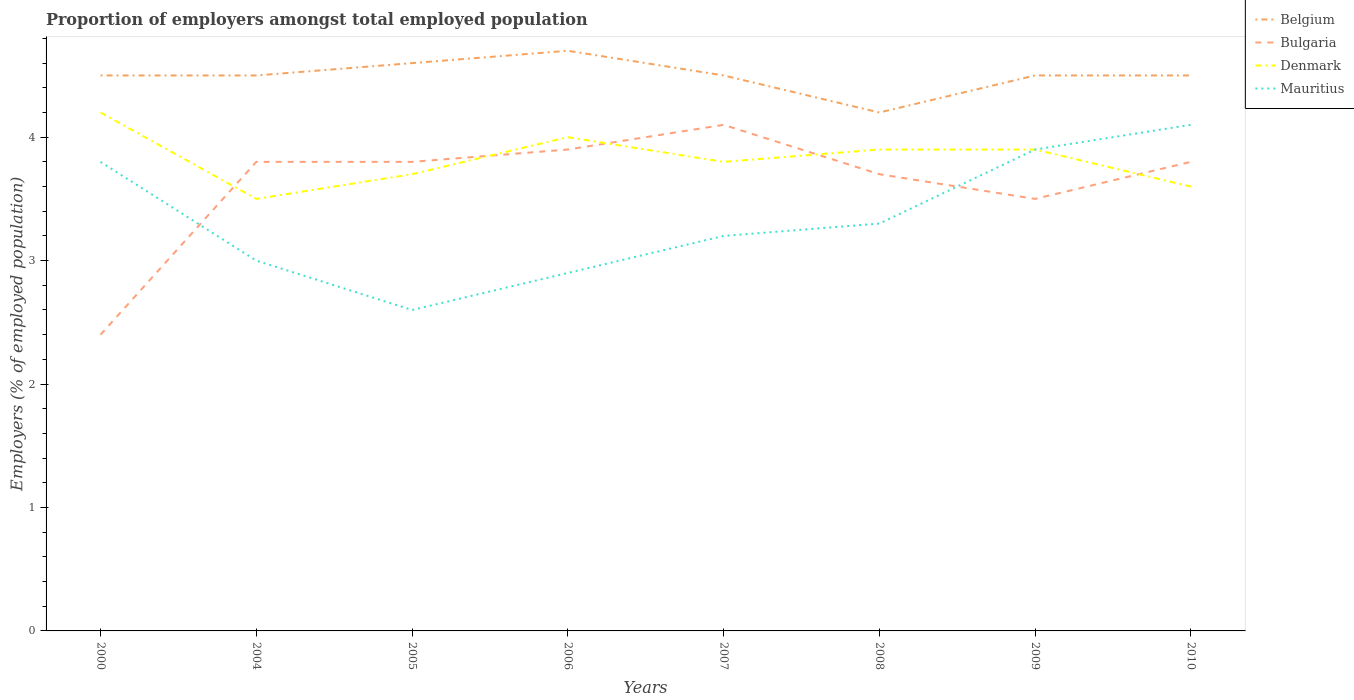Does the line corresponding to Bulgaria intersect with the line corresponding to Belgium?
Your answer should be very brief. No. Across all years, what is the maximum proportion of employers in Bulgaria?
Provide a short and direct response. 2.4. In which year was the proportion of employers in Mauritius maximum?
Make the answer very short. 2005. What is the total proportion of employers in Denmark in the graph?
Your response must be concise. -0.3. What is the difference between the highest and the second highest proportion of employers in Mauritius?
Keep it short and to the point. 1.5. What is the difference between the highest and the lowest proportion of employers in Mauritius?
Your response must be concise. 3. Is the proportion of employers in Bulgaria strictly greater than the proportion of employers in Denmark over the years?
Provide a short and direct response. No. How many lines are there?
Your answer should be very brief. 4. How many years are there in the graph?
Keep it short and to the point. 8. What is the difference between two consecutive major ticks on the Y-axis?
Ensure brevity in your answer.  1. Does the graph contain grids?
Your answer should be compact. No. How many legend labels are there?
Ensure brevity in your answer.  4. How are the legend labels stacked?
Your answer should be very brief. Vertical. What is the title of the graph?
Ensure brevity in your answer.  Proportion of employers amongst total employed population. Does "Somalia" appear as one of the legend labels in the graph?
Keep it short and to the point. No. What is the label or title of the Y-axis?
Your response must be concise. Employers (% of employed population). What is the Employers (% of employed population) of Bulgaria in 2000?
Keep it short and to the point. 2.4. What is the Employers (% of employed population) in Denmark in 2000?
Give a very brief answer. 4.2. What is the Employers (% of employed population) in Mauritius in 2000?
Your answer should be very brief. 3.8. What is the Employers (% of employed population) in Bulgaria in 2004?
Give a very brief answer. 3.8. What is the Employers (% of employed population) of Denmark in 2004?
Your answer should be compact. 3.5. What is the Employers (% of employed population) in Mauritius in 2004?
Keep it short and to the point. 3. What is the Employers (% of employed population) of Belgium in 2005?
Keep it short and to the point. 4.6. What is the Employers (% of employed population) in Bulgaria in 2005?
Ensure brevity in your answer.  3.8. What is the Employers (% of employed population) in Denmark in 2005?
Make the answer very short. 3.7. What is the Employers (% of employed population) in Mauritius in 2005?
Give a very brief answer. 2.6. What is the Employers (% of employed population) in Belgium in 2006?
Keep it short and to the point. 4.7. What is the Employers (% of employed population) in Bulgaria in 2006?
Your answer should be very brief. 3.9. What is the Employers (% of employed population) of Mauritius in 2006?
Give a very brief answer. 2.9. What is the Employers (% of employed population) in Belgium in 2007?
Your response must be concise. 4.5. What is the Employers (% of employed population) in Bulgaria in 2007?
Provide a short and direct response. 4.1. What is the Employers (% of employed population) in Denmark in 2007?
Provide a short and direct response. 3.8. What is the Employers (% of employed population) in Mauritius in 2007?
Offer a terse response. 3.2. What is the Employers (% of employed population) of Belgium in 2008?
Ensure brevity in your answer.  4.2. What is the Employers (% of employed population) of Bulgaria in 2008?
Your answer should be compact. 3.7. What is the Employers (% of employed population) of Denmark in 2008?
Give a very brief answer. 3.9. What is the Employers (% of employed population) of Mauritius in 2008?
Your answer should be compact. 3.3. What is the Employers (% of employed population) of Denmark in 2009?
Ensure brevity in your answer.  3.9. What is the Employers (% of employed population) of Mauritius in 2009?
Offer a terse response. 3.9. What is the Employers (% of employed population) of Bulgaria in 2010?
Provide a succinct answer. 3.8. What is the Employers (% of employed population) of Denmark in 2010?
Your answer should be very brief. 3.6. What is the Employers (% of employed population) of Mauritius in 2010?
Provide a short and direct response. 4.1. Across all years, what is the maximum Employers (% of employed population) in Belgium?
Ensure brevity in your answer.  4.7. Across all years, what is the maximum Employers (% of employed population) in Bulgaria?
Provide a succinct answer. 4.1. Across all years, what is the maximum Employers (% of employed population) in Denmark?
Your response must be concise. 4.2. Across all years, what is the maximum Employers (% of employed population) in Mauritius?
Provide a short and direct response. 4.1. Across all years, what is the minimum Employers (% of employed population) in Belgium?
Make the answer very short. 4.2. Across all years, what is the minimum Employers (% of employed population) in Bulgaria?
Ensure brevity in your answer.  2.4. Across all years, what is the minimum Employers (% of employed population) in Mauritius?
Provide a succinct answer. 2.6. What is the total Employers (% of employed population) in Belgium in the graph?
Keep it short and to the point. 36. What is the total Employers (% of employed population) in Bulgaria in the graph?
Your answer should be compact. 29. What is the total Employers (% of employed population) of Denmark in the graph?
Offer a very short reply. 30.6. What is the total Employers (% of employed population) in Mauritius in the graph?
Provide a short and direct response. 26.8. What is the difference between the Employers (% of employed population) of Belgium in 2000 and that in 2004?
Your response must be concise. 0. What is the difference between the Employers (% of employed population) of Mauritius in 2000 and that in 2004?
Provide a short and direct response. 0.8. What is the difference between the Employers (% of employed population) in Bulgaria in 2000 and that in 2005?
Make the answer very short. -1.4. What is the difference between the Employers (% of employed population) in Mauritius in 2000 and that in 2005?
Give a very brief answer. 1.2. What is the difference between the Employers (% of employed population) in Bulgaria in 2000 and that in 2006?
Give a very brief answer. -1.5. What is the difference between the Employers (% of employed population) of Denmark in 2000 and that in 2006?
Make the answer very short. 0.2. What is the difference between the Employers (% of employed population) of Belgium in 2000 and that in 2007?
Provide a succinct answer. 0. What is the difference between the Employers (% of employed population) in Bulgaria in 2000 and that in 2007?
Offer a very short reply. -1.7. What is the difference between the Employers (% of employed population) of Denmark in 2000 and that in 2007?
Provide a short and direct response. 0.4. What is the difference between the Employers (% of employed population) in Belgium in 2000 and that in 2008?
Give a very brief answer. 0.3. What is the difference between the Employers (% of employed population) in Bulgaria in 2000 and that in 2008?
Offer a terse response. -1.3. What is the difference between the Employers (% of employed population) of Mauritius in 2000 and that in 2008?
Your response must be concise. 0.5. What is the difference between the Employers (% of employed population) in Bulgaria in 2000 and that in 2009?
Ensure brevity in your answer.  -1.1. What is the difference between the Employers (% of employed population) of Belgium in 2000 and that in 2010?
Your response must be concise. 0. What is the difference between the Employers (% of employed population) of Bulgaria in 2000 and that in 2010?
Offer a very short reply. -1.4. What is the difference between the Employers (% of employed population) of Mauritius in 2000 and that in 2010?
Provide a succinct answer. -0.3. What is the difference between the Employers (% of employed population) in Mauritius in 2004 and that in 2005?
Offer a terse response. 0.4. What is the difference between the Employers (% of employed population) in Belgium in 2004 and that in 2006?
Offer a very short reply. -0.2. What is the difference between the Employers (% of employed population) of Denmark in 2004 and that in 2007?
Your response must be concise. -0.3. What is the difference between the Employers (% of employed population) of Bulgaria in 2004 and that in 2008?
Give a very brief answer. 0.1. What is the difference between the Employers (% of employed population) of Denmark in 2004 and that in 2008?
Provide a succinct answer. -0.4. What is the difference between the Employers (% of employed population) of Bulgaria in 2004 and that in 2009?
Give a very brief answer. 0.3. What is the difference between the Employers (% of employed population) in Denmark in 2004 and that in 2009?
Make the answer very short. -0.4. What is the difference between the Employers (% of employed population) in Denmark in 2004 and that in 2010?
Your answer should be very brief. -0.1. What is the difference between the Employers (% of employed population) in Mauritius in 2004 and that in 2010?
Your answer should be compact. -1.1. What is the difference between the Employers (% of employed population) of Belgium in 2005 and that in 2006?
Your answer should be very brief. -0.1. What is the difference between the Employers (% of employed population) of Bulgaria in 2005 and that in 2006?
Offer a very short reply. -0.1. What is the difference between the Employers (% of employed population) of Mauritius in 2005 and that in 2006?
Your answer should be very brief. -0.3. What is the difference between the Employers (% of employed population) in Belgium in 2005 and that in 2007?
Your answer should be very brief. 0.1. What is the difference between the Employers (% of employed population) in Denmark in 2005 and that in 2007?
Provide a short and direct response. -0.1. What is the difference between the Employers (% of employed population) of Belgium in 2005 and that in 2008?
Ensure brevity in your answer.  0.4. What is the difference between the Employers (% of employed population) of Bulgaria in 2005 and that in 2008?
Ensure brevity in your answer.  0.1. What is the difference between the Employers (% of employed population) in Denmark in 2005 and that in 2008?
Offer a terse response. -0.2. What is the difference between the Employers (% of employed population) of Mauritius in 2005 and that in 2008?
Provide a succinct answer. -0.7. What is the difference between the Employers (% of employed population) of Belgium in 2005 and that in 2009?
Offer a terse response. 0.1. What is the difference between the Employers (% of employed population) of Denmark in 2005 and that in 2009?
Make the answer very short. -0.2. What is the difference between the Employers (% of employed population) in Denmark in 2005 and that in 2010?
Offer a very short reply. 0.1. What is the difference between the Employers (% of employed population) of Mauritius in 2005 and that in 2010?
Your response must be concise. -1.5. What is the difference between the Employers (% of employed population) of Belgium in 2006 and that in 2007?
Offer a very short reply. 0.2. What is the difference between the Employers (% of employed population) in Denmark in 2006 and that in 2007?
Make the answer very short. 0.2. What is the difference between the Employers (% of employed population) in Mauritius in 2006 and that in 2007?
Keep it short and to the point. -0.3. What is the difference between the Employers (% of employed population) in Belgium in 2006 and that in 2008?
Provide a succinct answer. 0.5. What is the difference between the Employers (% of employed population) of Mauritius in 2006 and that in 2009?
Make the answer very short. -1. What is the difference between the Employers (% of employed population) in Bulgaria in 2006 and that in 2010?
Your answer should be compact. 0.1. What is the difference between the Employers (% of employed population) of Denmark in 2006 and that in 2010?
Your answer should be compact. 0.4. What is the difference between the Employers (% of employed population) of Mauritius in 2006 and that in 2010?
Your answer should be compact. -1.2. What is the difference between the Employers (% of employed population) of Denmark in 2007 and that in 2008?
Make the answer very short. -0.1. What is the difference between the Employers (% of employed population) of Belgium in 2007 and that in 2009?
Provide a succinct answer. 0. What is the difference between the Employers (% of employed population) in Bulgaria in 2007 and that in 2009?
Ensure brevity in your answer.  0.6. What is the difference between the Employers (% of employed population) of Denmark in 2007 and that in 2009?
Provide a succinct answer. -0.1. What is the difference between the Employers (% of employed population) of Denmark in 2007 and that in 2010?
Make the answer very short. 0.2. What is the difference between the Employers (% of employed population) in Mauritius in 2007 and that in 2010?
Offer a very short reply. -0.9. What is the difference between the Employers (% of employed population) of Belgium in 2008 and that in 2009?
Make the answer very short. -0.3. What is the difference between the Employers (% of employed population) of Bulgaria in 2008 and that in 2009?
Provide a short and direct response. 0.2. What is the difference between the Employers (% of employed population) in Denmark in 2008 and that in 2009?
Provide a short and direct response. 0. What is the difference between the Employers (% of employed population) of Mauritius in 2008 and that in 2009?
Offer a terse response. -0.6. What is the difference between the Employers (% of employed population) in Denmark in 2008 and that in 2010?
Your answer should be very brief. 0.3. What is the difference between the Employers (% of employed population) of Belgium in 2009 and that in 2010?
Provide a succinct answer. 0. What is the difference between the Employers (% of employed population) of Belgium in 2000 and the Employers (% of employed population) of Bulgaria in 2004?
Your answer should be very brief. 0.7. What is the difference between the Employers (% of employed population) of Belgium in 2000 and the Employers (% of employed population) of Denmark in 2004?
Ensure brevity in your answer.  1. What is the difference between the Employers (% of employed population) in Denmark in 2000 and the Employers (% of employed population) in Mauritius in 2004?
Your answer should be compact. 1.2. What is the difference between the Employers (% of employed population) in Belgium in 2000 and the Employers (% of employed population) in Bulgaria in 2005?
Offer a very short reply. 0.7. What is the difference between the Employers (% of employed population) in Belgium in 2000 and the Employers (% of employed population) in Denmark in 2005?
Ensure brevity in your answer.  0.8. What is the difference between the Employers (% of employed population) in Bulgaria in 2000 and the Employers (% of employed population) in Denmark in 2006?
Give a very brief answer. -1.6. What is the difference between the Employers (% of employed population) in Denmark in 2000 and the Employers (% of employed population) in Mauritius in 2006?
Your answer should be compact. 1.3. What is the difference between the Employers (% of employed population) in Bulgaria in 2000 and the Employers (% of employed population) in Denmark in 2007?
Your answer should be very brief. -1.4. What is the difference between the Employers (% of employed population) in Denmark in 2000 and the Employers (% of employed population) in Mauritius in 2007?
Provide a succinct answer. 1. What is the difference between the Employers (% of employed population) in Denmark in 2000 and the Employers (% of employed population) in Mauritius in 2008?
Ensure brevity in your answer.  0.9. What is the difference between the Employers (% of employed population) of Belgium in 2000 and the Employers (% of employed population) of Bulgaria in 2009?
Provide a short and direct response. 1. What is the difference between the Employers (% of employed population) in Belgium in 2000 and the Employers (% of employed population) in Denmark in 2009?
Offer a very short reply. 0.6. What is the difference between the Employers (% of employed population) of Belgium in 2000 and the Employers (% of employed population) of Bulgaria in 2010?
Your response must be concise. 0.7. What is the difference between the Employers (% of employed population) of Belgium in 2000 and the Employers (% of employed population) of Mauritius in 2010?
Give a very brief answer. 0.4. What is the difference between the Employers (% of employed population) in Bulgaria in 2000 and the Employers (% of employed population) in Mauritius in 2010?
Give a very brief answer. -1.7. What is the difference between the Employers (% of employed population) in Belgium in 2004 and the Employers (% of employed population) in Bulgaria in 2005?
Provide a succinct answer. 0.7. What is the difference between the Employers (% of employed population) in Belgium in 2004 and the Employers (% of employed population) in Denmark in 2005?
Provide a short and direct response. 0.8. What is the difference between the Employers (% of employed population) in Belgium in 2004 and the Employers (% of employed population) in Mauritius in 2005?
Your response must be concise. 1.9. What is the difference between the Employers (% of employed population) in Bulgaria in 2004 and the Employers (% of employed population) in Mauritius in 2005?
Your answer should be compact. 1.2. What is the difference between the Employers (% of employed population) in Denmark in 2004 and the Employers (% of employed population) in Mauritius in 2005?
Provide a short and direct response. 0.9. What is the difference between the Employers (% of employed population) of Bulgaria in 2004 and the Employers (% of employed population) of Denmark in 2006?
Provide a succinct answer. -0.2. What is the difference between the Employers (% of employed population) in Bulgaria in 2004 and the Employers (% of employed population) in Mauritius in 2006?
Make the answer very short. 0.9. What is the difference between the Employers (% of employed population) in Denmark in 2004 and the Employers (% of employed population) in Mauritius in 2006?
Provide a succinct answer. 0.6. What is the difference between the Employers (% of employed population) of Belgium in 2004 and the Employers (% of employed population) of Mauritius in 2007?
Your answer should be very brief. 1.3. What is the difference between the Employers (% of employed population) of Denmark in 2004 and the Employers (% of employed population) of Mauritius in 2007?
Your answer should be compact. 0.3. What is the difference between the Employers (% of employed population) in Belgium in 2004 and the Employers (% of employed population) in Denmark in 2008?
Provide a succinct answer. 0.6. What is the difference between the Employers (% of employed population) in Belgium in 2004 and the Employers (% of employed population) in Mauritius in 2008?
Your answer should be compact. 1.2. What is the difference between the Employers (% of employed population) of Bulgaria in 2004 and the Employers (% of employed population) of Mauritius in 2008?
Offer a very short reply. 0.5. What is the difference between the Employers (% of employed population) of Denmark in 2004 and the Employers (% of employed population) of Mauritius in 2008?
Make the answer very short. 0.2. What is the difference between the Employers (% of employed population) in Belgium in 2004 and the Employers (% of employed population) in Denmark in 2009?
Give a very brief answer. 0.6. What is the difference between the Employers (% of employed population) in Belgium in 2004 and the Employers (% of employed population) in Mauritius in 2009?
Your answer should be compact. 0.6. What is the difference between the Employers (% of employed population) in Bulgaria in 2004 and the Employers (% of employed population) in Denmark in 2009?
Provide a short and direct response. -0.1. What is the difference between the Employers (% of employed population) in Bulgaria in 2004 and the Employers (% of employed population) in Mauritius in 2009?
Give a very brief answer. -0.1. What is the difference between the Employers (% of employed population) in Denmark in 2004 and the Employers (% of employed population) in Mauritius in 2009?
Offer a terse response. -0.4. What is the difference between the Employers (% of employed population) of Belgium in 2004 and the Employers (% of employed population) of Mauritius in 2010?
Keep it short and to the point. 0.4. What is the difference between the Employers (% of employed population) in Bulgaria in 2004 and the Employers (% of employed population) in Denmark in 2010?
Your answer should be very brief. 0.2. What is the difference between the Employers (% of employed population) in Denmark in 2005 and the Employers (% of employed population) in Mauritius in 2006?
Your answer should be compact. 0.8. What is the difference between the Employers (% of employed population) of Belgium in 2005 and the Employers (% of employed population) of Bulgaria in 2007?
Your answer should be very brief. 0.5. What is the difference between the Employers (% of employed population) in Belgium in 2005 and the Employers (% of employed population) in Mauritius in 2007?
Ensure brevity in your answer.  1.4. What is the difference between the Employers (% of employed population) in Bulgaria in 2005 and the Employers (% of employed population) in Denmark in 2007?
Keep it short and to the point. 0. What is the difference between the Employers (% of employed population) in Bulgaria in 2005 and the Employers (% of employed population) in Mauritius in 2007?
Provide a short and direct response. 0.6. What is the difference between the Employers (% of employed population) of Belgium in 2005 and the Employers (% of employed population) of Denmark in 2008?
Offer a terse response. 0.7. What is the difference between the Employers (% of employed population) of Belgium in 2005 and the Employers (% of employed population) of Mauritius in 2008?
Keep it short and to the point. 1.3. What is the difference between the Employers (% of employed population) of Belgium in 2005 and the Employers (% of employed population) of Bulgaria in 2009?
Your response must be concise. 1.1. What is the difference between the Employers (% of employed population) in Belgium in 2005 and the Employers (% of employed population) in Denmark in 2009?
Make the answer very short. 0.7. What is the difference between the Employers (% of employed population) of Bulgaria in 2005 and the Employers (% of employed population) of Denmark in 2009?
Give a very brief answer. -0.1. What is the difference between the Employers (% of employed population) in Bulgaria in 2005 and the Employers (% of employed population) in Mauritius in 2009?
Your response must be concise. -0.1. What is the difference between the Employers (% of employed population) in Denmark in 2005 and the Employers (% of employed population) in Mauritius in 2009?
Give a very brief answer. -0.2. What is the difference between the Employers (% of employed population) in Belgium in 2005 and the Employers (% of employed population) in Mauritius in 2010?
Give a very brief answer. 0.5. What is the difference between the Employers (% of employed population) in Bulgaria in 2005 and the Employers (% of employed population) in Denmark in 2010?
Your answer should be compact. 0.2. What is the difference between the Employers (% of employed population) of Belgium in 2006 and the Employers (% of employed population) of Bulgaria in 2007?
Ensure brevity in your answer.  0.6. What is the difference between the Employers (% of employed population) in Belgium in 2006 and the Employers (% of employed population) in Bulgaria in 2008?
Your answer should be compact. 1. What is the difference between the Employers (% of employed population) in Bulgaria in 2006 and the Employers (% of employed population) in Denmark in 2008?
Ensure brevity in your answer.  0. What is the difference between the Employers (% of employed population) in Bulgaria in 2006 and the Employers (% of employed population) in Mauritius in 2008?
Your answer should be compact. 0.6. What is the difference between the Employers (% of employed population) of Belgium in 2006 and the Employers (% of employed population) of Denmark in 2009?
Your answer should be compact. 0.8. What is the difference between the Employers (% of employed population) in Belgium in 2006 and the Employers (% of employed population) in Mauritius in 2009?
Your answer should be compact. 0.8. What is the difference between the Employers (% of employed population) in Bulgaria in 2006 and the Employers (% of employed population) in Denmark in 2009?
Offer a terse response. 0. What is the difference between the Employers (% of employed population) of Denmark in 2006 and the Employers (% of employed population) of Mauritius in 2009?
Keep it short and to the point. 0.1. What is the difference between the Employers (% of employed population) of Belgium in 2006 and the Employers (% of employed population) of Bulgaria in 2010?
Make the answer very short. 0.9. What is the difference between the Employers (% of employed population) in Belgium in 2006 and the Employers (% of employed population) in Mauritius in 2010?
Offer a very short reply. 0.6. What is the difference between the Employers (% of employed population) of Bulgaria in 2006 and the Employers (% of employed population) of Denmark in 2010?
Offer a very short reply. 0.3. What is the difference between the Employers (% of employed population) in Denmark in 2007 and the Employers (% of employed population) in Mauritius in 2008?
Your answer should be very brief. 0.5. What is the difference between the Employers (% of employed population) of Belgium in 2007 and the Employers (% of employed population) of Bulgaria in 2009?
Offer a very short reply. 1. What is the difference between the Employers (% of employed population) of Belgium in 2007 and the Employers (% of employed population) of Mauritius in 2010?
Keep it short and to the point. 0.4. What is the difference between the Employers (% of employed population) of Bulgaria in 2007 and the Employers (% of employed population) of Denmark in 2010?
Provide a succinct answer. 0.5. What is the difference between the Employers (% of employed population) in Bulgaria in 2007 and the Employers (% of employed population) in Mauritius in 2010?
Your answer should be compact. 0. What is the difference between the Employers (% of employed population) of Bulgaria in 2008 and the Employers (% of employed population) of Denmark in 2009?
Keep it short and to the point. -0.2. What is the difference between the Employers (% of employed population) in Bulgaria in 2008 and the Employers (% of employed population) in Mauritius in 2009?
Your answer should be compact. -0.2. What is the difference between the Employers (% of employed population) of Denmark in 2008 and the Employers (% of employed population) of Mauritius in 2009?
Offer a terse response. 0. What is the difference between the Employers (% of employed population) of Belgium in 2008 and the Employers (% of employed population) of Denmark in 2010?
Your answer should be compact. 0.6. What is the difference between the Employers (% of employed population) of Bulgaria in 2008 and the Employers (% of employed population) of Denmark in 2010?
Your response must be concise. 0.1. What is the difference between the Employers (% of employed population) of Bulgaria in 2008 and the Employers (% of employed population) of Mauritius in 2010?
Ensure brevity in your answer.  -0.4. What is the difference between the Employers (% of employed population) of Belgium in 2009 and the Employers (% of employed population) of Mauritius in 2010?
Your answer should be very brief. 0.4. What is the difference between the Employers (% of employed population) in Bulgaria in 2009 and the Employers (% of employed population) in Mauritius in 2010?
Offer a terse response. -0.6. What is the average Employers (% of employed population) of Belgium per year?
Provide a succinct answer. 4.5. What is the average Employers (% of employed population) in Bulgaria per year?
Give a very brief answer. 3.62. What is the average Employers (% of employed population) in Denmark per year?
Make the answer very short. 3.83. What is the average Employers (% of employed population) of Mauritius per year?
Keep it short and to the point. 3.35. In the year 2000, what is the difference between the Employers (% of employed population) of Bulgaria and Employers (% of employed population) of Denmark?
Ensure brevity in your answer.  -1.8. In the year 2004, what is the difference between the Employers (% of employed population) of Belgium and Employers (% of employed population) of Denmark?
Offer a very short reply. 1. In the year 2004, what is the difference between the Employers (% of employed population) of Denmark and Employers (% of employed population) of Mauritius?
Your response must be concise. 0.5. In the year 2005, what is the difference between the Employers (% of employed population) in Belgium and Employers (% of employed population) in Mauritius?
Offer a terse response. 2. In the year 2005, what is the difference between the Employers (% of employed population) of Bulgaria and Employers (% of employed population) of Denmark?
Offer a terse response. 0.1. In the year 2005, what is the difference between the Employers (% of employed population) in Bulgaria and Employers (% of employed population) in Mauritius?
Your response must be concise. 1.2. In the year 2006, what is the difference between the Employers (% of employed population) in Belgium and Employers (% of employed population) in Denmark?
Make the answer very short. 0.7. In the year 2006, what is the difference between the Employers (% of employed population) in Belgium and Employers (% of employed population) in Mauritius?
Your answer should be compact. 1.8. In the year 2006, what is the difference between the Employers (% of employed population) in Denmark and Employers (% of employed population) in Mauritius?
Ensure brevity in your answer.  1.1. In the year 2007, what is the difference between the Employers (% of employed population) of Belgium and Employers (% of employed population) of Bulgaria?
Your answer should be very brief. 0.4. In the year 2007, what is the difference between the Employers (% of employed population) in Belgium and Employers (% of employed population) in Denmark?
Make the answer very short. 0.7. In the year 2007, what is the difference between the Employers (% of employed population) in Belgium and Employers (% of employed population) in Mauritius?
Keep it short and to the point. 1.3. In the year 2007, what is the difference between the Employers (% of employed population) of Denmark and Employers (% of employed population) of Mauritius?
Ensure brevity in your answer.  0.6. In the year 2008, what is the difference between the Employers (% of employed population) of Belgium and Employers (% of employed population) of Bulgaria?
Provide a succinct answer. 0.5. In the year 2008, what is the difference between the Employers (% of employed population) in Belgium and Employers (% of employed population) in Denmark?
Offer a terse response. 0.3. In the year 2008, what is the difference between the Employers (% of employed population) of Bulgaria and Employers (% of employed population) of Denmark?
Provide a short and direct response. -0.2. In the year 2008, what is the difference between the Employers (% of employed population) in Bulgaria and Employers (% of employed population) in Mauritius?
Offer a terse response. 0.4. In the year 2009, what is the difference between the Employers (% of employed population) of Belgium and Employers (% of employed population) of Mauritius?
Your answer should be very brief. 0.6. In the year 2009, what is the difference between the Employers (% of employed population) in Bulgaria and Employers (% of employed population) in Denmark?
Your answer should be very brief. -0.4. In the year 2009, what is the difference between the Employers (% of employed population) in Bulgaria and Employers (% of employed population) in Mauritius?
Provide a succinct answer. -0.4. In the year 2010, what is the difference between the Employers (% of employed population) of Belgium and Employers (% of employed population) of Bulgaria?
Provide a succinct answer. 0.7. In the year 2010, what is the difference between the Employers (% of employed population) of Belgium and Employers (% of employed population) of Denmark?
Offer a terse response. 0.9. In the year 2010, what is the difference between the Employers (% of employed population) of Denmark and Employers (% of employed population) of Mauritius?
Offer a very short reply. -0.5. What is the ratio of the Employers (% of employed population) of Belgium in 2000 to that in 2004?
Your answer should be very brief. 1. What is the ratio of the Employers (% of employed population) of Bulgaria in 2000 to that in 2004?
Offer a terse response. 0.63. What is the ratio of the Employers (% of employed population) in Mauritius in 2000 to that in 2004?
Offer a terse response. 1.27. What is the ratio of the Employers (% of employed population) in Belgium in 2000 to that in 2005?
Offer a very short reply. 0.98. What is the ratio of the Employers (% of employed population) of Bulgaria in 2000 to that in 2005?
Your answer should be compact. 0.63. What is the ratio of the Employers (% of employed population) in Denmark in 2000 to that in 2005?
Offer a terse response. 1.14. What is the ratio of the Employers (% of employed population) in Mauritius in 2000 to that in 2005?
Your answer should be compact. 1.46. What is the ratio of the Employers (% of employed population) in Belgium in 2000 to that in 2006?
Offer a very short reply. 0.96. What is the ratio of the Employers (% of employed population) of Bulgaria in 2000 to that in 2006?
Ensure brevity in your answer.  0.62. What is the ratio of the Employers (% of employed population) in Denmark in 2000 to that in 2006?
Provide a short and direct response. 1.05. What is the ratio of the Employers (% of employed population) in Mauritius in 2000 to that in 2006?
Provide a short and direct response. 1.31. What is the ratio of the Employers (% of employed population) in Belgium in 2000 to that in 2007?
Offer a terse response. 1. What is the ratio of the Employers (% of employed population) in Bulgaria in 2000 to that in 2007?
Keep it short and to the point. 0.59. What is the ratio of the Employers (% of employed population) in Denmark in 2000 to that in 2007?
Make the answer very short. 1.11. What is the ratio of the Employers (% of employed population) of Mauritius in 2000 to that in 2007?
Your answer should be compact. 1.19. What is the ratio of the Employers (% of employed population) in Belgium in 2000 to that in 2008?
Ensure brevity in your answer.  1.07. What is the ratio of the Employers (% of employed population) in Bulgaria in 2000 to that in 2008?
Provide a short and direct response. 0.65. What is the ratio of the Employers (% of employed population) of Denmark in 2000 to that in 2008?
Provide a short and direct response. 1.08. What is the ratio of the Employers (% of employed population) in Mauritius in 2000 to that in 2008?
Offer a terse response. 1.15. What is the ratio of the Employers (% of employed population) in Bulgaria in 2000 to that in 2009?
Keep it short and to the point. 0.69. What is the ratio of the Employers (% of employed population) in Denmark in 2000 to that in 2009?
Make the answer very short. 1.08. What is the ratio of the Employers (% of employed population) of Mauritius in 2000 to that in 2009?
Give a very brief answer. 0.97. What is the ratio of the Employers (% of employed population) of Bulgaria in 2000 to that in 2010?
Provide a succinct answer. 0.63. What is the ratio of the Employers (% of employed population) of Denmark in 2000 to that in 2010?
Your answer should be compact. 1.17. What is the ratio of the Employers (% of employed population) in Mauritius in 2000 to that in 2010?
Your response must be concise. 0.93. What is the ratio of the Employers (% of employed population) in Belgium in 2004 to that in 2005?
Provide a succinct answer. 0.98. What is the ratio of the Employers (% of employed population) in Denmark in 2004 to that in 2005?
Make the answer very short. 0.95. What is the ratio of the Employers (% of employed population) of Mauritius in 2004 to that in 2005?
Provide a succinct answer. 1.15. What is the ratio of the Employers (% of employed population) of Belgium in 2004 to that in 2006?
Offer a very short reply. 0.96. What is the ratio of the Employers (% of employed population) in Bulgaria in 2004 to that in 2006?
Keep it short and to the point. 0.97. What is the ratio of the Employers (% of employed population) in Denmark in 2004 to that in 2006?
Provide a succinct answer. 0.88. What is the ratio of the Employers (% of employed population) in Mauritius in 2004 to that in 2006?
Offer a terse response. 1.03. What is the ratio of the Employers (% of employed population) in Belgium in 2004 to that in 2007?
Give a very brief answer. 1. What is the ratio of the Employers (% of employed population) in Bulgaria in 2004 to that in 2007?
Give a very brief answer. 0.93. What is the ratio of the Employers (% of employed population) of Denmark in 2004 to that in 2007?
Provide a short and direct response. 0.92. What is the ratio of the Employers (% of employed population) of Belgium in 2004 to that in 2008?
Your answer should be very brief. 1.07. What is the ratio of the Employers (% of employed population) of Bulgaria in 2004 to that in 2008?
Keep it short and to the point. 1.03. What is the ratio of the Employers (% of employed population) of Denmark in 2004 to that in 2008?
Your answer should be very brief. 0.9. What is the ratio of the Employers (% of employed population) of Belgium in 2004 to that in 2009?
Ensure brevity in your answer.  1. What is the ratio of the Employers (% of employed population) of Bulgaria in 2004 to that in 2009?
Keep it short and to the point. 1.09. What is the ratio of the Employers (% of employed population) of Denmark in 2004 to that in 2009?
Give a very brief answer. 0.9. What is the ratio of the Employers (% of employed population) in Mauritius in 2004 to that in 2009?
Your answer should be compact. 0.77. What is the ratio of the Employers (% of employed population) of Denmark in 2004 to that in 2010?
Ensure brevity in your answer.  0.97. What is the ratio of the Employers (% of employed population) in Mauritius in 2004 to that in 2010?
Your answer should be compact. 0.73. What is the ratio of the Employers (% of employed population) in Belgium in 2005 to that in 2006?
Make the answer very short. 0.98. What is the ratio of the Employers (% of employed population) in Bulgaria in 2005 to that in 2006?
Provide a succinct answer. 0.97. What is the ratio of the Employers (% of employed population) in Denmark in 2005 to that in 2006?
Offer a terse response. 0.93. What is the ratio of the Employers (% of employed population) of Mauritius in 2005 to that in 2006?
Provide a succinct answer. 0.9. What is the ratio of the Employers (% of employed population) in Belgium in 2005 to that in 2007?
Your answer should be very brief. 1.02. What is the ratio of the Employers (% of employed population) in Bulgaria in 2005 to that in 2007?
Your answer should be compact. 0.93. What is the ratio of the Employers (% of employed population) of Denmark in 2005 to that in 2007?
Provide a short and direct response. 0.97. What is the ratio of the Employers (% of employed population) in Mauritius in 2005 to that in 2007?
Offer a very short reply. 0.81. What is the ratio of the Employers (% of employed population) of Belgium in 2005 to that in 2008?
Offer a terse response. 1.1. What is the ratio of the Employers (% of employed population) in Denmark in 2005 to that in 2008?
Ensure brevity in your answer.  0.95. What is the ratio of the Employers (% of employed population) of Mauritius in 2005 to that in 2008?
Give a very brief answer. 0.79. What is the ratio of the Employers (% of employed population) of Belgium in 2005 to that in 2009?
Provide a short and direct response. 1.02. What is the ratio of the Employers (% of employed population) in Bulgaria in 2005 to that in 2009?
Give a very brief answer. 1.09. What is the ratio of the Employers (% of employed population) in Denmark in 2005 to that in 2009?
Your answer should be very brief. 0.95. What is the ratio of the Employers (% of employed population) in Belgium in 2005 to that in 2010?
Ensure brevity in your answer.  1.02. What is the ratio of the Employers (% of employed population) in Denmark in 2005 to that in 2010?
Your response must be concise. 1.03. What is the ratio of the Employers (% of employed population) of Mauritius in 2005 to that in 2010?
Keep it short and to the point. 0.63. What is the ratio of the Employers (% of employed population) in Belgium in 2006 to that in 2007?
Offer a very short reply. 1.04. What is the ratio of the Employers (% of employed population) of Bulgaria in 2006 to that in 2007?
Offer a very short reply. 0.95. What is the ratio of the Employers (% of employed population) of Denmark in 2006 to that in 2007?
Provide a short and direct response. 1.05. What is the ratio of the Employers (% of employed population) of Mauritius in 2006 to that in 2007?
Your answer should be very brief. 0.91. What is the ratio of the Employers (% of employed population) in Belgium in 2006 to that in 2008?
Your response must be concise. 1.12. What is the ratio of the Employers (% of employed population) in Bulgaria in 2006 to that in 2008?
Offer a terse response. 1.05. What is the ratio of the Employers (% of employed population) in Denmark in 2006 to that in 2008?
Keep it short and to the point. 1.03. What is the ratio of the Employers (% of employed population) in Mauritius in 2006 to that in 2008?
Your answer should be compact. 0.88. What is the ratio of the Employers (% of employed population) in Belgium in 2006 to that in 2009?
Your answer should be very brief. 1.04. What is the ratio of the Employers (% of employed population) of Bulgaria in 2006 to that in 2009?
Your answer should be very brief. 1.11. What is the ratio of the Employers (% of employed population) of Denmark in 2006 to that in 2009?
Your answer should be very brief. 1.03. What is the ratio of the Employers (% of employed population) in Mauritius in 2006 to that in 2009?
Provide a short and direct response. 0.74. What is the ratio of the Employers (% of employed population) in Belgium in 2006 to that in 2010?
Provide a short and direct response. 1.04. What is the ratio of the Employers (% of employed population) in Bulgaria in 2006 to that in 2010?
Keep it short and to the point. 1.03. What is the ratio of the Employers (% of employed population) in Mauritius in 2006 to that in 2010?
Keep it short and to the point. 0.71. What is the ratio of the Employers (% of employed population) in Belgium in 2007 to that in 2008?
Provide a succinct answer. 1.07. What is the ratio of the Employers (% of employed population) in Bulgaria in 2007 to that in 2008?
Keep it short and to the point. 1.11. What is the ratio of the Employers (% of employed population) in Denmark in 2007 to that in 2008?
Keep it short and to the point. 0.97. What is the ratio of the Employers (% of employed population) in Mauritius in 2007 to that in 2008?
Make the answer very short. 0.97. What is the ratio of the Employers (% of employed population) in Belgium in 2007 to that in 2009?
Offer a very short reply. 1. What is the ratio of the Employers (% of employed population) in Bulgaria in 2007 to that in 2009?
Make the answer very short. 1.17. What is the ratio of the Employers (% of employed population) in Denmark in 2007 to that in 2009?
Give a very brief answer. 0.97. What is the ratio of the Employers (% of employed population) of Mauritius in 2007 to that in 2009?
Provide a short and direct response. 0.82. What is the ratio of the Employers (% of employed population) of Belgium in 2007 to that in 2010?
Give a very brief answer. 1. What is the ratio of the Employers (% of employed population) in Bulgaria in 2007 to that in 2010?
Make the answer very short. 1.08. What is the ratio of the Employers (% of employed population) in Denmark in 2007 to that in 2010?
Make the answer very short. 1.06. What is the ratio of the Employers (% of employed population) in Mauritius in 2007 to that in 2010?
Make the answer very short. 0.78. What is the ratio of the Employers (% of employed population) of Bulgaria in 2008 to that in 2009?
Provide a short and direct response. 1.06. What is the ratio of the Employers (% of employed population) of Denmark in 2008 to that in 2009?
Provide a short and direct response. 1. What is the ratio of the Employers (% of employed population) of Mauritius in 2008 to that in 2009?
Your response must be concise. 0.85. What is the ratio of the Employers (% of employed population) in Belgium in 2008 to that in 2010?
Offer a terse response. 0.93. What is the ratio of the Employers (% of employed population) of Bulgaria in 2008 to that in 2010?
Give a very brief answer. 0.97. What is the ratio of the Employers (% of employed population) in Mauritius in 2008 to that in 2010?
Your answer should be very brief. 0.8. What is the ratio of the Employers (% of employed population) of Bulgaria in 2009 to that in 2010?
Make the answer very short. 0.92. What is the ratio of the Employers (% of employed population) in Denmark in 2009 to that in 2010?
Provide a short and direct response. 1.08. What is the ratio of the Employers (% of employed population) of Mauritius in 2009 to that in 2010?
Offer a terse response. 0.95. What is the difference between the highest and the second highest Employers (% of employed population) of Belgium?
Make the answer very short. 0.1. What is the difference between the highest and the second highest Employers (% of employed population) in Denmark?
Your answer should be very brief. 0.2. What is the difference between the highest and the lowest Employers (% of employed population) in Belgium?
Give a very brief answer. 0.5. What is the difference between the highest and the lowest Employers (% of employed population) in Bulgaria?
Keep it short and to the point. 1.7. What is the difference between the highest and the lowest Employers (% of employed population) of Denmark?
Your response must be concise. 0.7. 